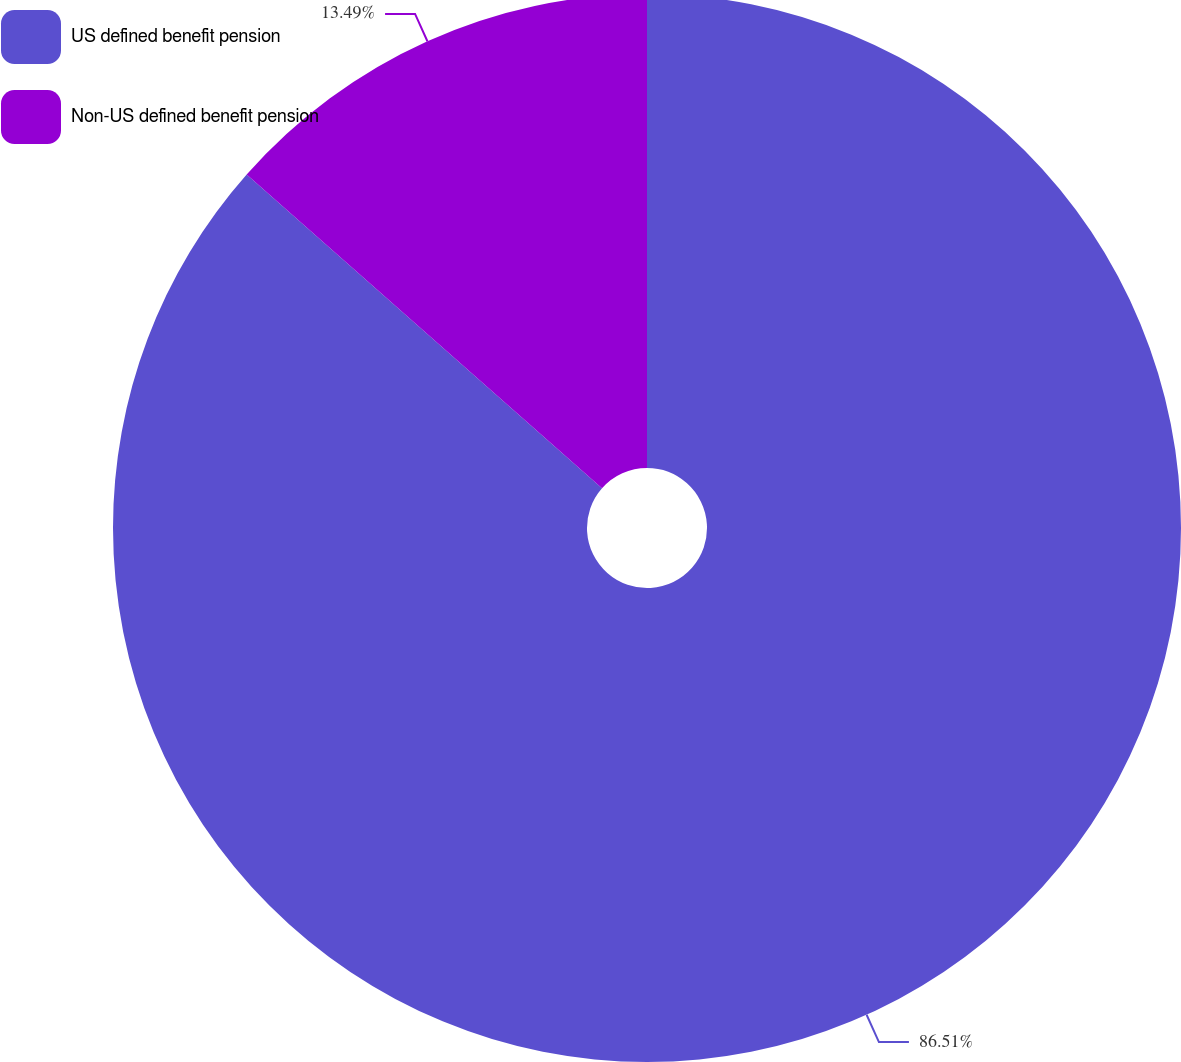<chart> <loc_0><loc_0><loc_500><loc_500><pie_chart><fcel>US defined benefit pension<fcel>Non-US defined benefit pension<nl><fcel>86.51%<fcel>13.49%<nl></chart> 